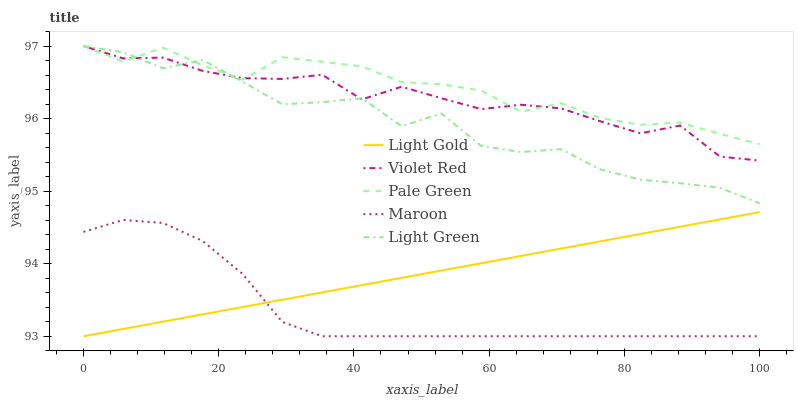Does Maroon have the minimum area under the curve?
Answer yes or no. Yes. Does Pale Green have the maximum area under the curve?
Answer yes or no. Yes. Does Light Gold have the minimum area under the curve?
Answer yes or no. No. Does Light Gold have the maximum area under the curve?
Answer yes or no. No. Is Light Gold the smoothest?
Answer yes or no. Yes. Is Light Green the roughest?
Answer yes or no. Yes. Is Pale Green the smoothest?
Answer yes or no. No. Is Pale Green the roughest?
Answer yes or no. No. Does Light Gold have the lowest value?
Answer yes or no. Yes. Does Pale Green have the lowest value?
Answer yes or no. No. Does Light Green have the highest value?
Answer yes or no. Yes. Does Light Gold have the highest value?
Answer yes or no. No. Is Maroon less than Light Green?
Answer yes or no. Yes. Is Pale Green greater than Light Gold?
Answer yes or no. Yes. Does Light Green intersect Violet Red?
Answer yes or no. Yes. Is Light Green less than Violet Red?
Answer yes or no. No. Is Light Green greater than Violet Red?
Answer yes or no. No. Does Maroon intersect Light Green?
Answer yes or no. No. 